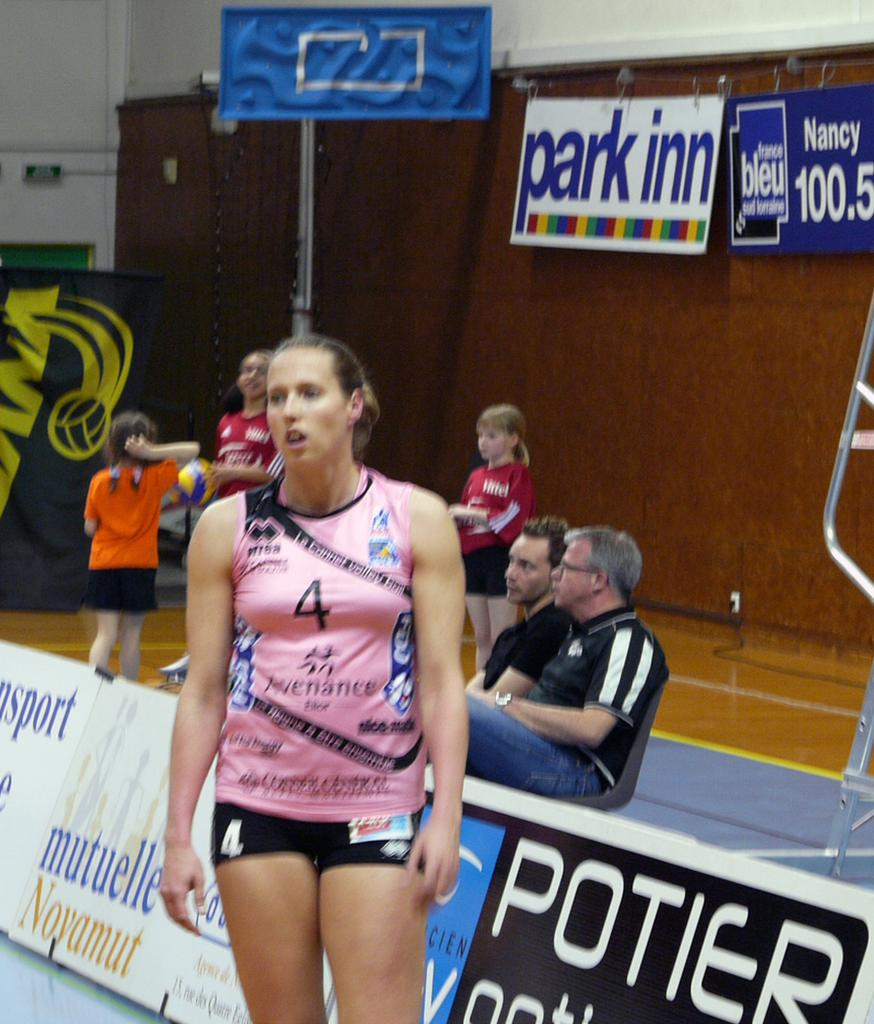<image>
Provide a brief description of the given image. a lady that has the number 4 on their outfit 